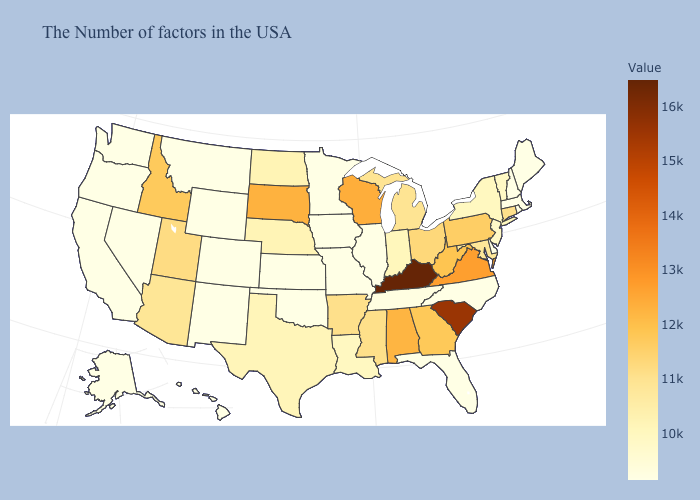Does Kentucky have the highest value in the USA?
Quick response, please. Yes. Which states have the lowest value in the West?
Keep it brief. Wyoming, Colorado, New Mexico, Montana, Nevada, California, Washington, Oregon, Alaska, Hawaii. Does Nebraska have the highest value in the USA?
Be succinct. No. Which states have the highest value in the USA?
Quick response, please. Kentucky. Among the states that border Alabama , does Tennessee have the highest value?
Concise answer only. No. Does Wyoming have the highest value in the USA?
Give a very brief answer. No. 